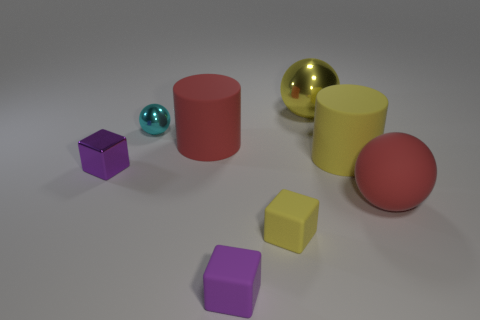Add 1 yellow rubber cubes. How many objects exist? 9 Subtract all balls. How many objects are left? 5 Add 7 tiny blocks. How many tiny blocks exist? 10 Subtract 1 yellow cylinders. How many objects are left? 7 Subtract all small matte objects. Subtract all red rubber spheres. How many objects are left? 5 Add 7 big cylinders. How many big cylinders are left? 9 